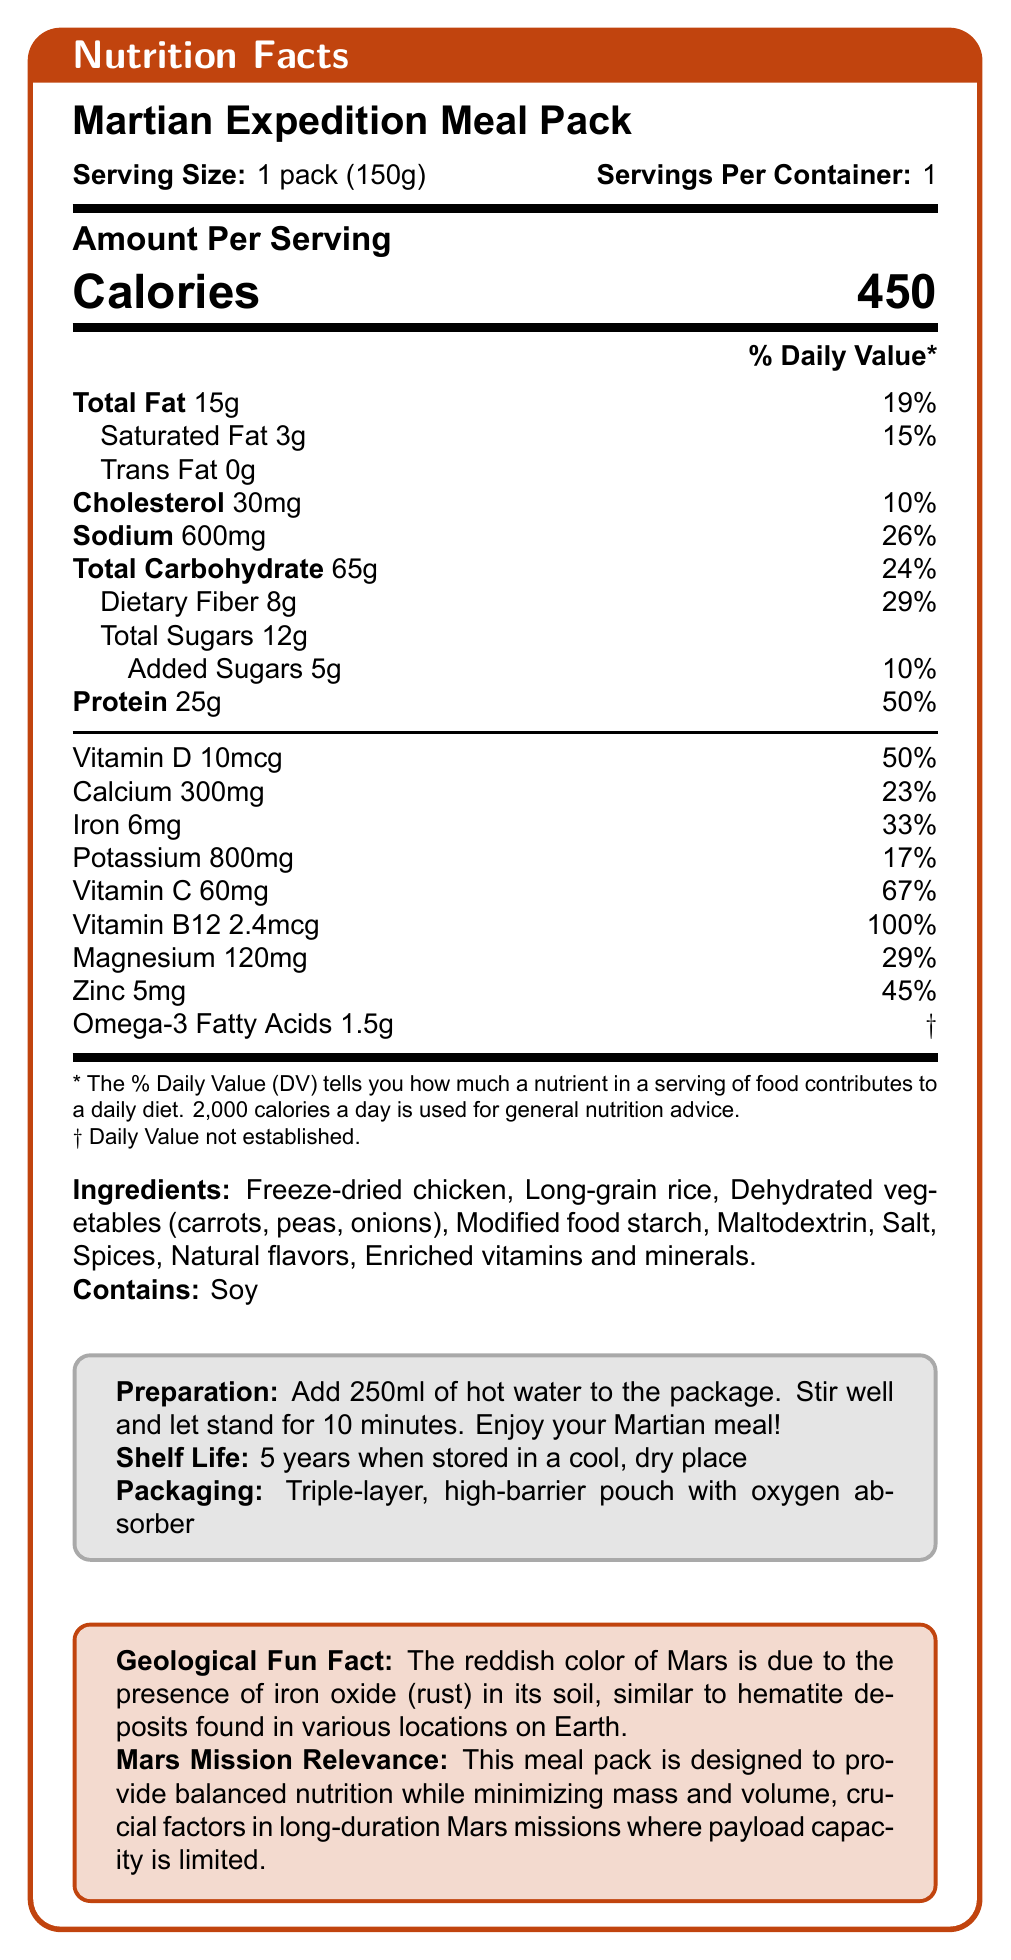what is the serving size? The serving size is clearly stated as "1 pack (150g)" in the document.
Answer: 1 pack (150g) how many calories are in one serving? The calorie content per serving is explicitly mentioned as "450 calories" in the document.
Answer: 450 calories what is the amount of protein in the meal pack? The document lists 25g of protein per serving in the Nutrition Facts section.
Answer: 25g what are the preparation instructions? The preparation instructions are provided in a separate section under "Preparation."
Answer: Add 250ml of hot water to the package. Stir well and let stand for 10 minutes. Enjoy your Martian meal! how long is the shelf life of the meal pack? The shelf life is mentioned as "5 years when stored in a cool, dry place."
Answer: 5 years when stored in a cool, dry place how much calcium is in the meal pack? A. 150mg B. 300mg C. 450mg D. 600mg The document specifies the calcium content as 300mg per serving.
Answer: B. 300mg which of the following is true about the packaging of the meal pack? I. It has a triple-layer. II. It has an oxygen absorber. III. It has a zipper seal. The packaging is described as a "Triple-layer, high-barrier pouch with oxygen absorber," so statements I and II are true, but there is no mention of a zipper seal (III).
Answer: I and II only does the meal pack contain soy? The allergens section lists "Contains: Soy," indicating that the meal pack contains soy.
Answer: Yes describe the main idea of the document. The document primarily focuses on the nutritional composition and usage information of the Martian Expedition Meal Pack, aiming to meet the dietary needs of astronauts on long-duration Mars missions.
Answer: The document provides detailed nutrition facts and relevant information about the Martian Expedition Meal Pack, a freeze-dried food product designed for long-duration Mars missions. It includes serving size, nutritional values, ingredients, preparation instructions, shelf life, and packaging details. Additionally, it highlights a fun geological fact related to Mars and explains the meal pack's relevance for space missions. how much sodium is in the meal pack? The sodium content per serving is listed as 600mg in the document.
Answer: 600mg what percentage of the daily value of vitamin C does the meal pack contain? The document states that the meal pack contains 67% of the daily value for vitamin C.
Answer: 67% can I determine the iron content in milligrams from the document? The document states that the iron content is 6mg per serving.
Answer: Yes what is the main source of protein in the meal pack? A. Rice B. Chicken C. Vegetables D. Soy According to the ingredients list, the main source of protein is likely "Freeze-dried chicken."
Answer: B. Chicken is there any information on whether the meal pack is gluten-free? The document does not provide any information regarding whether the meal pack is gluten-free.
Answer: Cannot be determined what is the purpose of the meal pack in the context of a Mars mission? The document states that the meal pack is designed to offer balanced nutrition and minimize mass and volume for Mars missions.
Answer: To provide balanced nutrition while minimizing mass and volume, crucial for long-duration Mars missions with limited payload capacity. 